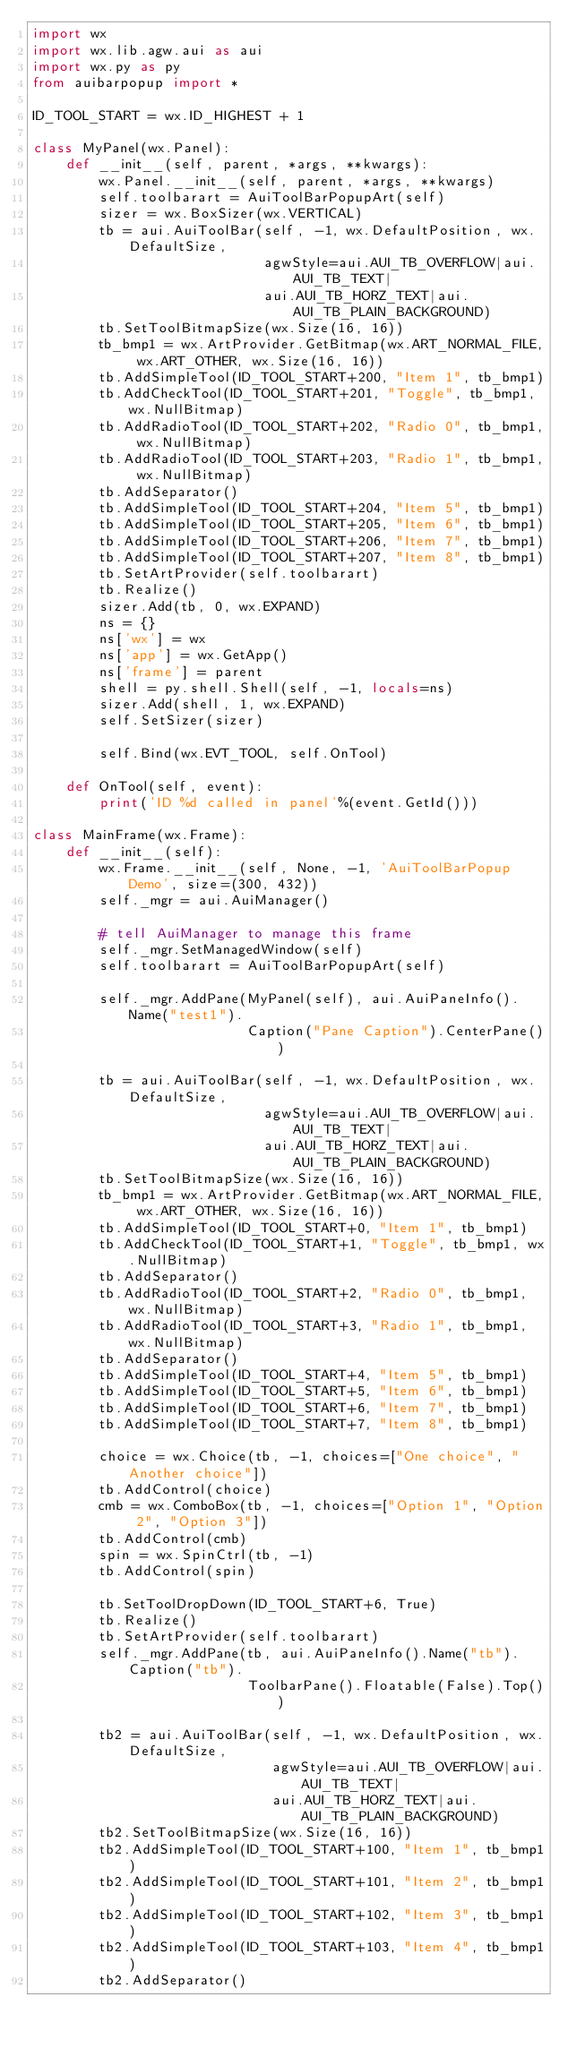Convert code to text. <code><loc_0><loc_0><loc_500><loc_500><_Python_>import wx
import wx.lib.agw.aui as aui
import wx.py as py
from auibarpopup import *

ID_TOOL_START = wx.ID_HIGHEST + 1

class MyPanel(wx.Panel):
    def __init__(self, parent, *args, **kwargs):
        wx.Panel.__init__(self, parent, *args, **kwargs)
        self.toolbarart = AuiToolBarPopupArt(self)
        sizer = wx.BoxSizer(wx.VERTICAL)
        tb = aui.AuiToolBar(self, -1, wx.DefaultPosition, wx.DefaultSize,
                            agwStyle=aui.AUI_TB_OVERFLOW|aui.AUI_TB_TEXT|
                            aui.AUI_TB_HORZ_TEXT|aui.AUI_TB_PLAIN_BACKGROUND)
        tb.SetToolBitmapSize(wx.Size(16, 16))
        tb_bmp1 = wx.ArtProvider.GetBitmap(wx.ART_NORMAL_FILE, wx.ART_OTHER, wx.Size(16, 16))
        tb.AddSimpleTool(ID_TOOL_START+200, "Item 1", tb_bmp1)
        tb.AddCheckTool(ID_TOOL_START+201, "Toggle", tb_bmp1, wx.NullBitmap)
        tb.AddRadioTool(ID_TOOL_START+202, "Radio 0", tb_bmp1, wx.NullBitmap)
        tb.AddRadioTool(ID_TOOL_START+203, "Radio 1", tb_bmp1, wx.NullBitmap)
        tb.AddSeparator()
        tb.AddSimpleTool(ID_TOOL_START+204, "Item 5", tb_bmp1)
        tb.AddSimpleTool(ID_TOOL_START+205, "Item 6", tb_bmp1)
        tb.AddSimpleTool(ID_TOOL_START+206, "Item 7", tb_bmp1)
        tb.AddSimpleTool(ID_TOOL_START+207, "Item 8", tb_bmp1)
        tb.SetArtProvider(self.toolbarart)
        tb.Realize()
        sizer.Add(tb, 0, wx.EXPAND)
        ns = {}
        ns['wx'] = wx
        ns['app'] = wx.GetApp()
        ns['frame'] = parent
        shell = py.shell.Shell(self, -1, locals=ns)
        sizer.Add(shell, 1, wx.EXPAND)
        self.SetSizer(sizer)

        self.Bind(wx.EVT_TOOL, self.OnTool)

    def OnTool(self, event):
        print('ID %d called in panel'%(event.GetId()))

class MainFrame(wx.Frame):
    def __init__(self):
        wx.Frame.__init__(self, None, -1, 'AuiToolBarPopup Demo', size=(300, 432))
        self._mgr = aui.AuiManager()

        # tell AuiManager to manage this frame
        self._mgr.SetManagedWindow(self)
        self.toolbarart = AuiToolBarPopupArt(self)

        self._mgr.AddPane(MyPanel(self), aui.AuiPaneInfo().Name("test1").
                          Caption("Pane Caption").CenterPane())

        tb = aui.AuiToolBar(self, -1, wx.DefaultPosition, wx.DefaultSize,
                            agwStyle=aui.AUI_TB_OVERFLOW|aui.AUI_TB_TEXT|
                            aui.AUI_TB_HORZ_TEXT|aui.AUI_TB_PLAIN_BACKGROUND)
        tb.SetToolBitmapSize(wx.Size(16, 16))
        tb_bmp1 = wx.ArtProvider.GetBitmap(wx.ART_NORMAL_FILE, wx.ART_OTHER, wx.Size(16, 16))
        tb.AddSimpleTool(ID_TOOL_START+0, "Item 1", tb_bmp1)
        tb.AddCheckTool(ID_TOOL_START+1, "Toggle", tb_bmp1, wx.NullBitmap)
        tb.AddSeparator()
        tb.AddRadioTool(ID_TOOL_START+2, "Radio 0", tb_bmp1, wx.NullBitmap)
        tb.AddRadioTool(ID_TOOL_START+3, "Radio 1", tb_bmp1, wx.NullBitmap)
        tb.AddSeparator()
        tb.AddSimpleTool(ID_TOOL_START+4, "Item 5", tb_bmp1)
        tb.AddSimpleTool(ID_TOOL_START+5, "Item 6", tb_bmp1)
        tb.AddSimpleTool(ID_TOOL_START+6, "Item 7", tb_bmp1)
        tb.AddSimpleTool(ID_TOOL_START+7, "Item 8", tb_bmp1)

        choice = wx.Choice(tb, -1, choices=["One choice", "Another choice"])
        tb.AddControl(choice)
        cmb = wx.ComboBox(tb, -1, choices=["Option 1", "Option 2", "Option 3"])
        tb.AddControl(cmb)
        spin = wx.SpinCtrl(tb, -1)
        tb.AddControl(spin)

        tb.SetToolDropDown(ID_TOOL_START+6, True)
        tb.Realize()
        tb.SetArtProvider(self.toolbarart)
        self._mgr.AddPane(tb, aui.AuiPaneInfo().Name("tb").Caption("tb").
                          ToolbarPane().Floatable(False).Top())

        tb2 = aui.AuiToolBar(self, -1, wx.DefaultPosition, wx.DefaultSize,
                             agwStyle=aui.AUI_TB_OVERFLOW|aui.AUI_TB_TEXT|
                             aui.AUI_TB_HORZ_TEXT|aui.AUI_TB_PLAIN_BACKGROUND)
        tb2.SetToolBitmapSize(wx.Size(16, 16))
        tb2.AddSimpleTool(ID_TOOL_START+100, "Item 1", tb_bmp1)
        tb2.AddSimpleTool(ID_TOOL_START+101, "Item 2", tb_bmp1)
        tb2.AddSimpleTool(ID_TOOL_START+102, "Item 3", tb_bmp1)
        tb2.AddSimpleTool(ID_TOOL_START+103, "Item 4", tb_bmp1)
        tb2.AddSeparator()</code> 